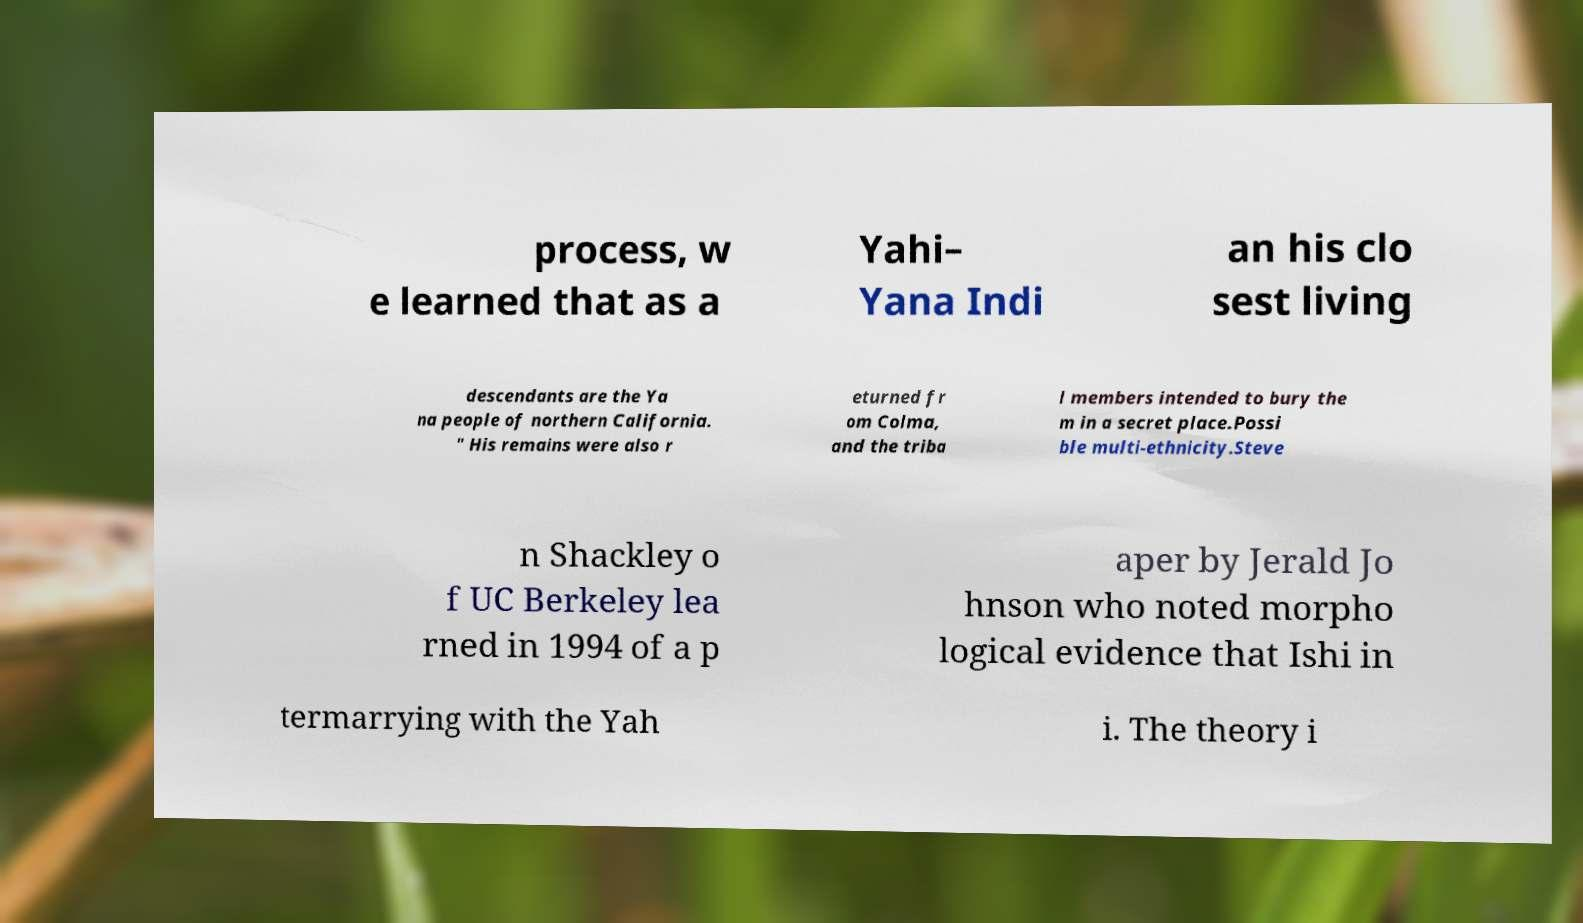Can you read and provide the text displayed in the image?This photo seems to have some interesting text. Can you extract and type it out for me? process, w e learned that as a Yahi– Yana Indi an his clo sest living descendants are the Ya na people of northern California. " His remains were also r eturned fr om Colma, and the triba l members intended to bury the m in a secret place.Possi ble multi-ethnicity.Steve n Shackley o f UC Berkeley lea rned in 1994 of a p aper by Jerald Jo hnson who noted morpho logical evidence that Ishi in termarrying with the Yah i. The theory i 